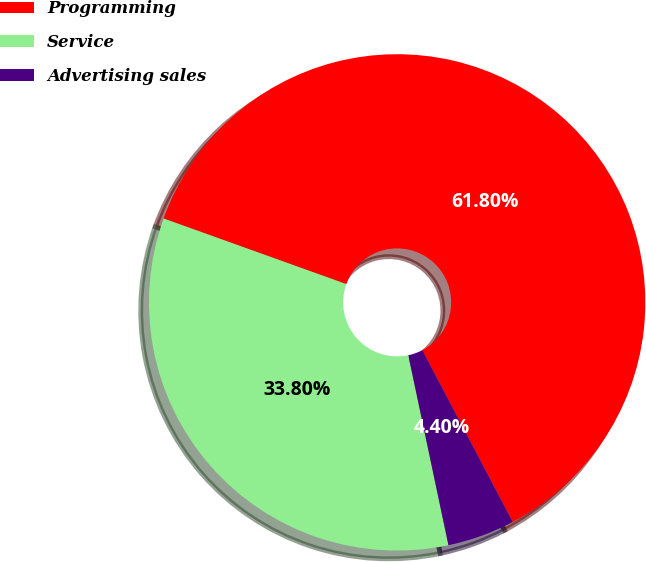Convert chart to OTSL. <chart><loc_0><loc_0><loc_500><loc_500><pie_chart><fcel>Programming<fcel>Service<fcel>Advertising sales<nl><fcel>61.8%<fcel>33.8%<fcel>4.4%<nl></chart> 